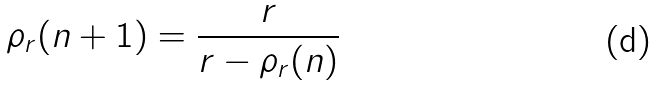<formula> <loc_0><loc_0><loc_500><loc_500>\rho _ { r } ( n + 1 ) = \frac { r } { r - \rho _ { r } ( n ) }</formula> 